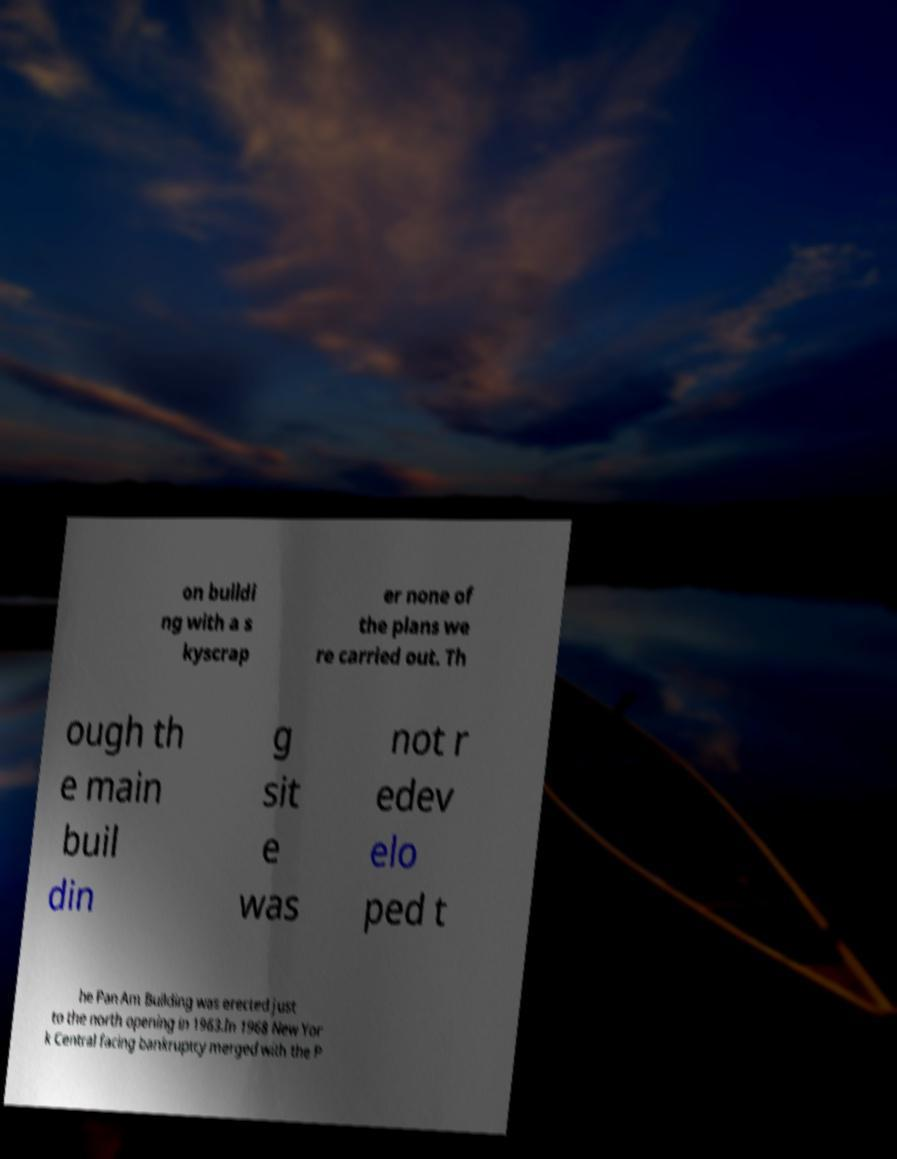Can you accurately transcribe the text from the provided image for me? on buildi ng with a s kyscrap er none of the plans we re carried out. Th ough th e main buil din g sit e was not r edev elo ped t he Pan Am Building was erected just to the north opening in 1963.In 1968 New Yor k Central facing bankruptcy merged with the P 